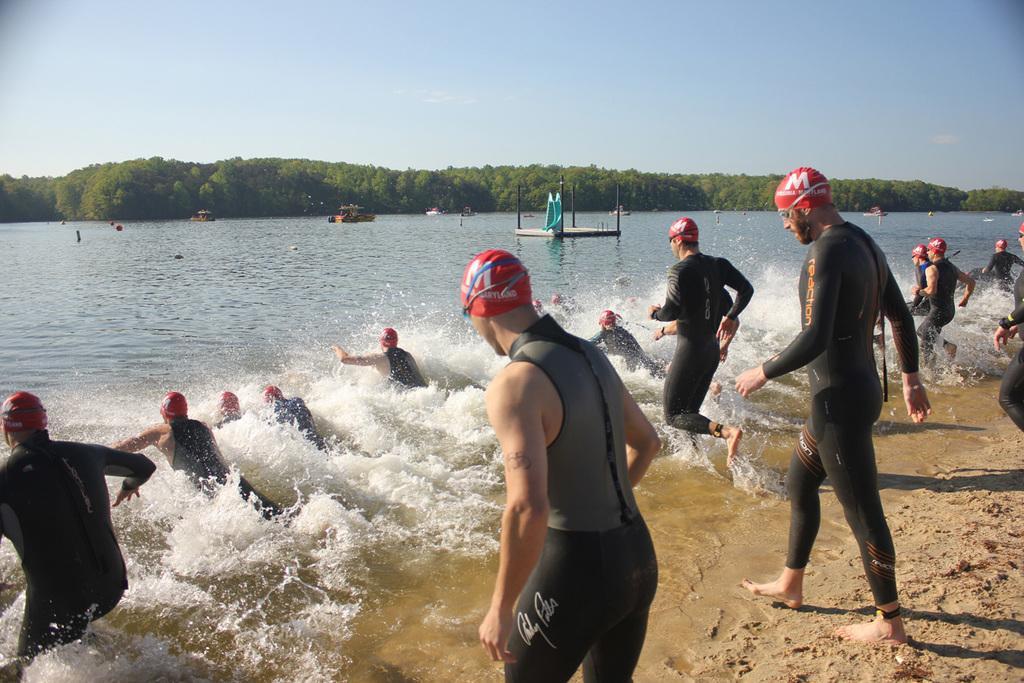Describe this image in one or two sentences. In this image we can see a few people, among them, some people are in the water, there are boats, trees and some other objects, in the background, we can see the sky. 